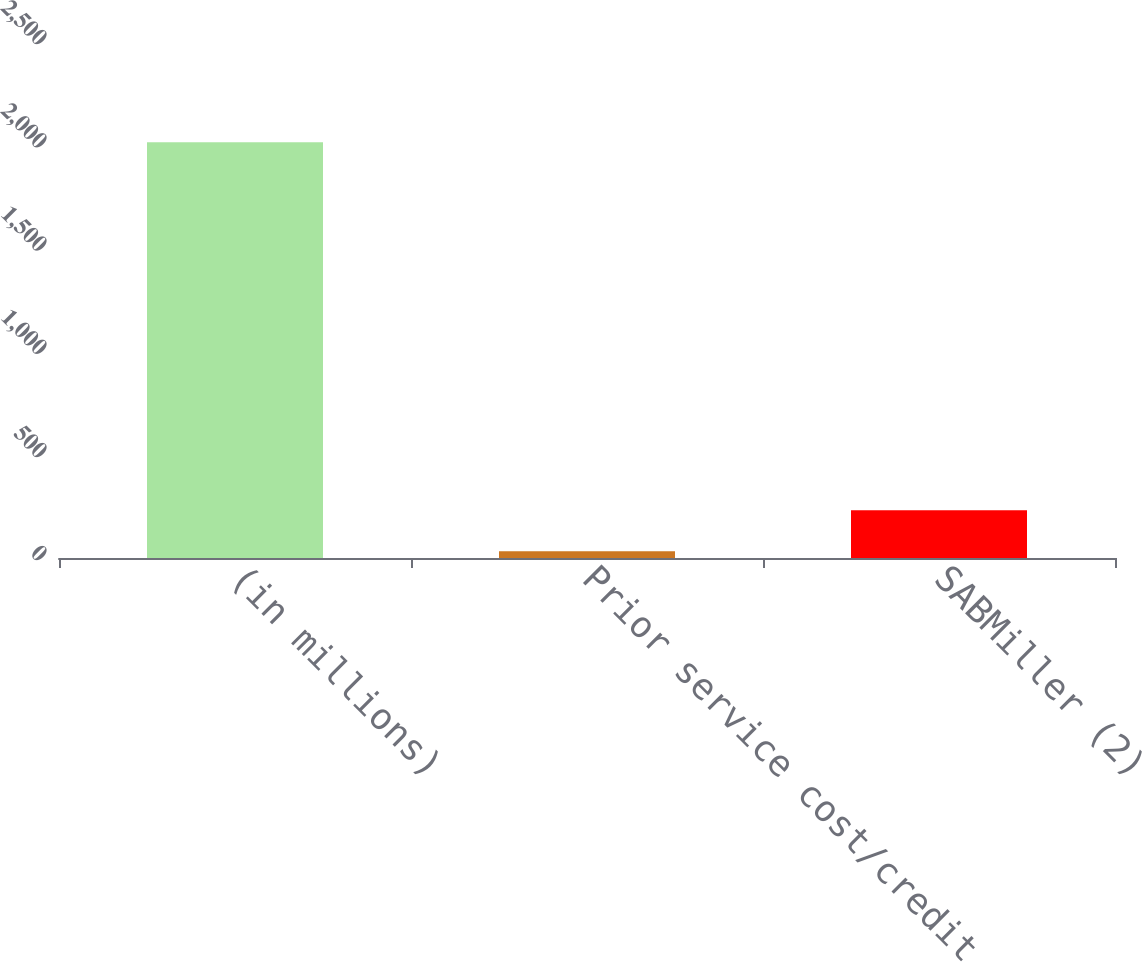<chart> <loc_0><loc_0><loc_500><loc_500><bar_chart><fcel>(in millions)<fcel>Prior service cost/credit<fcel>SABMiller (2)<nl><fcel>2014<fcel>33<fcel>231.1<nl></chart> 